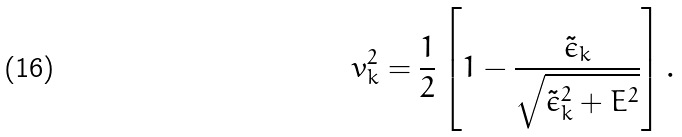Convert formula to latex. <formula><loc_0><loc_0><loc_500><loc_500>v ^ { 2 } _ { k } = \frac { 1 } { 2 } \left [ 1 - \frac { \tilde { \epsilon } _ { k } } { \sqrt { \tilde { \epsilon } _ { k } ^ { 2 } + E ^ { 2 } } } \right ] .</formula> 